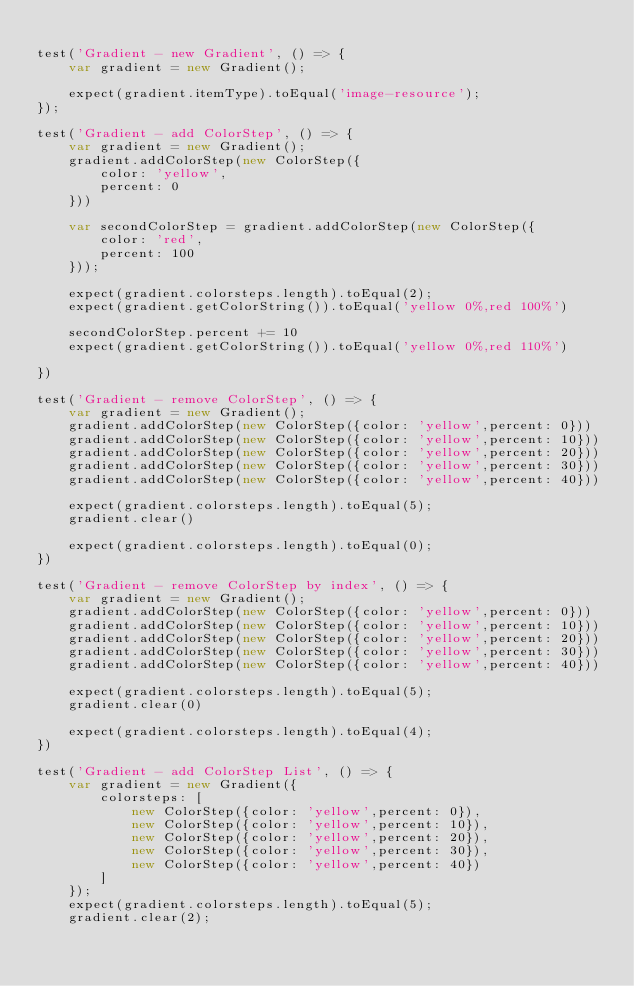<code> <loc_0><loc_0><loc_500><loc_500><_JavaScript_> 
test('Gradient - new Gradient', () => {
    var gradient = new Gradient();

    expect(gradient.itemType).toEqual('image-resource');
});

test('Gradient - add ColorStep', () => {
    var gradient = new Gradient();
    gradient.addColorStep(new ColorStep({
        color: 'yellow',
        percent: 0
    }))

    var secondColorStep = gradient.addColorStep(new ColorStep({
        color: 'red',
        percent: 100
    }));

    expect(gradient.colorsteps.length).toEqual(2);
    expect(gradient.getColorString()).toEqual('yellow 0%,red 100%')

    secondColorStep.percent += 10
    expect(gradient.getColorString()).toEqual('yellow 0%,red 110%')

})

test('Gradient - remove ColorStep', () => {
    var gradient = new Gradient();
    gradient.addColorStep(new ColorStep({color: 'yellow',percent: 0}))
    gradient.addColorStep(new ColorStep({color: 'yellow',percent: 10}))
    gradient.addColorStep(new ColorStep({color: 'yellow',percent: 20}))
    gradient.addColorStep(new ColorStep({color: 'yellow',percent: 30}))
    gradient.addColorStep(new ColorStep({color: 'yellow',percent: 40}))

    expect(gradient.colorsteps.length).toEqual(5);
    gradient.clear()

    expect(gradient.colorsteps.length).toEqual(0);
})

test('Gradient - remove ColorStep by index', () => {
    var gradient = new Gradient();
    gradient.addColorStep(new ColorStep({color: 'yellow',percent: 0}))
    gradient.addColorStep(new ColorStep({color: 'yellow',percent: 10}))
    gradient.addColorStep(new ColorStep({color: 'yellow',percent: 20}))
    gradient.addColorStep(new ColorStep({color: 'yellow',percent: 30}))
    gradient.addColorStep(new ColorStep({color: 'yellow',percent: 40}))

    expect(gradient.colorsteps.length).toEqual(5);
    gradient.clear(0)

    expect(gradient.colorsteps.length).toEqual(4);
})

test('Gradient - add ColorStep List', () => {
    var gradient = new Gradient({
        colorsteps: [
            new ColorStep({color: 'yellow',percent: 0}),
            new ColorStep({color: 'yellow',percent: 10}),
            new ColorStep({color: 'yellow',percent: 20}),
            new ColorStep({color: 'yellow',percent: 30}),
            new ColorStep({color: 'yellow',percent: 40})
        ]
    });
    expect(gradient.colorsteps.length).toEqual(5);
    gradient.clear(2);
</code> 